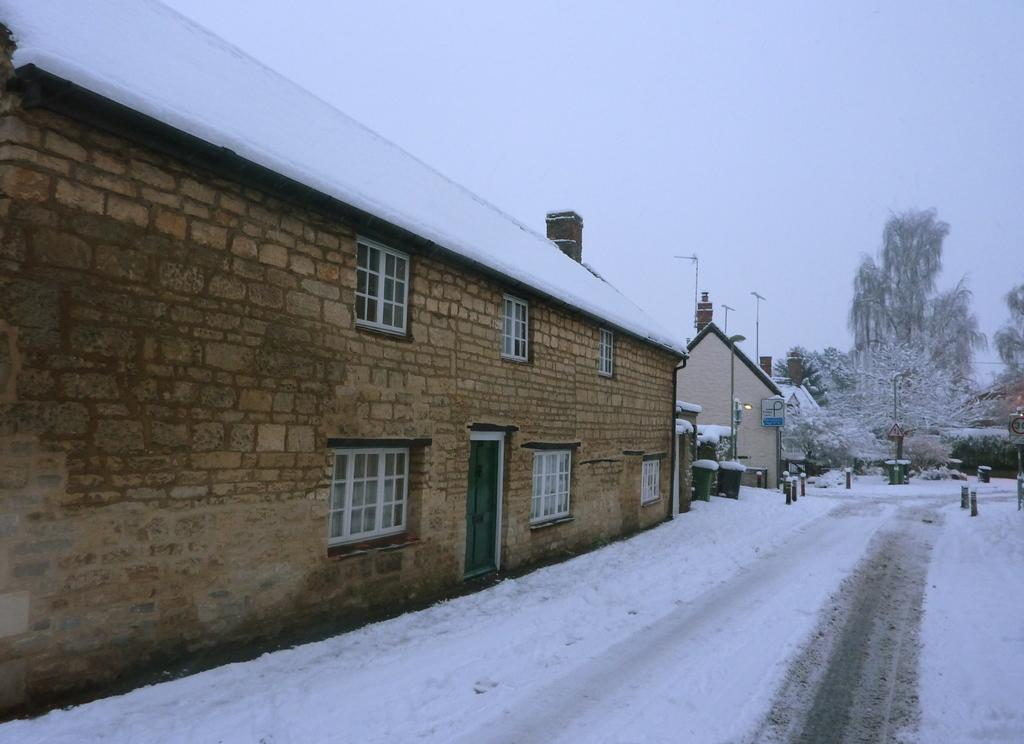What is the weather condition depicted in the image? There is snow in the image, indicating a cold and wintry condition. What type of structures can be seen in the image? There are houses in the image. What objects are present in the image that might be related to infrastructure? There are poles and lights visible in the image. What items are present for waste disposal in the image? There are dustbins in the image. What can be seen in the background of the image? There are trees and the sky visible in the background of the image. Where is the army stationed in the image? There is no army present in the image. How many floors can be seen in the lift in the image? There is no lift present in the image. 